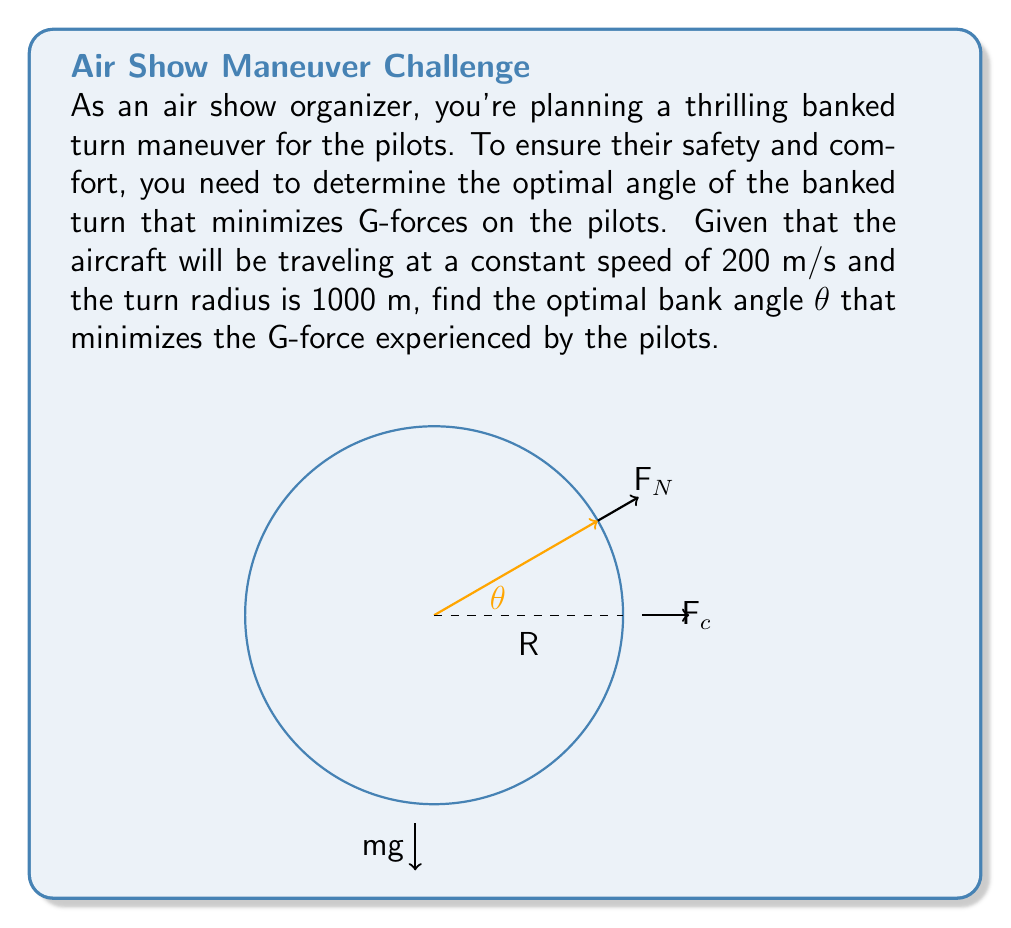Provide a solution to this math problem. Let's approach this step-by-step:

1) In a banked turn, there are three main forces acting on the aircraft:
   - Weight (mg)
   - Centripetal force (F$_c$)
   - Normal force from the wings (F$_N$)

2) The centripetal force is given by:

   $$F_c = \frac{mv^2}{R}$$

   where $m$ is the mass of the aircraft, $v$ is the velocity, and $R$ is the radius of the turn.

3) For the turn to be balanced, the vertical component of the normal force must equal the weight, and the horizontal component must equal the centripetal force:

   $$F_N \cos\theta = mg$$
   $$F_N \sin\theta = \frac{mv^2}{R}$$

4) Dividing these equations:

   $$\tan\theta = \frac{v^2}{gR}$$

5) Substituting the given values ($v = 200$ m/s, $R = 1000$ m, $g = 9.8$ m/s²):

   $$\tan\theta = \frac{200^2}{9.8 \cdot 1000} \approx 4.0816$$

6) Taking the inverse tangent:

   $$\theta = \arctan(4.0816) \approx 76.22°$$

7) The G-force experienced by the pilots is given by:

   $$G = \frac{F_N}{mg} = \frac{1}{\cos\theta}$$

8) At this angle, the G-force is:

   $$G = \frac{1}{\cos(76.22°)} \approx 4.17$$

This is the minimum G-force for this speed and turn radius.
Answer: $\theta \approx 76.22°$ 